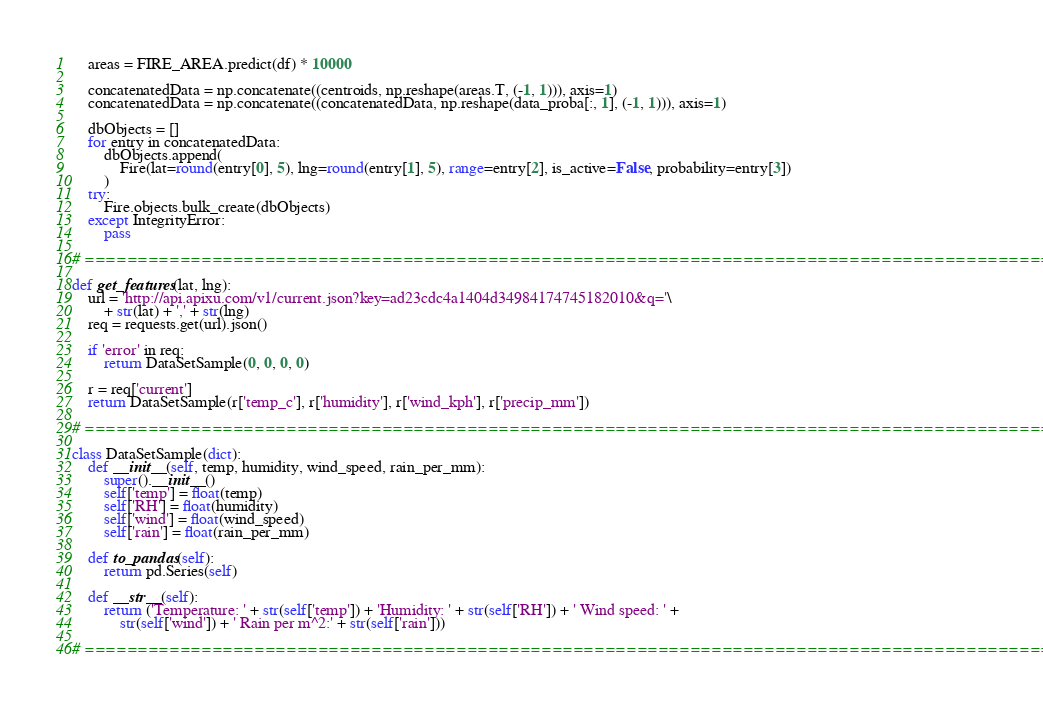<code> <loc_0><loc_0><loc_500><loc_500><_Python_>    areas = FIRE_AREA.predict(df) * 10000

    concatenatedData = np.concatenate((centroids, np.reshape(areas.T, (-1, 1))), axis=1)
    concatenatedData = np.concatenate((concatenatedData, np.reshape(data_proba[:, 1], (-1, 1))), axis=1)

    dbObjects = []
    for entry in concatenatedData:
        dbObjects.append(
            Fire(lat=round(entry[0], 5), lng=round(entry[1], 5), range=entry[2], is_active=False, probability=entry[3])
        )
    try:
        Fire.objects.bulk_create(dbObjects)
    except IntegrityError:
        pass

# ====================================================================================================

def get_features(lat, lng):
    url = 'http://api.apixu.com/v1/current.json?key=ad23cdc4a1404d34984174745182010&q='\
        + str(lat) + ',' + str(lng)
    req = requests.get(url).json()

    if 'error' in req:
        return DataSetSample(0, 0, 0, 0)

    r = req['current']
    return DataSetSample(r['temp_c'], r['humidity'], r['wind_kph'], r['precip_mm'])

# ====================================================================================================

class DataSetSample(dict):
    def __init__(self, temp, humidity, wind_speed, rain_per_mm):
        super().__init__()
        self['temp'] = float(temp)
        self['RH'] = float(humidity)
        self['wind'] = float(wind_speed)
        self['rain'] = float(rain_per_mm)

    def to_pandas(self):
        return pd.Series(self)

    def __str__(self):
        return ('Temperature: ' + str(self['temp']) + 'Humidity: ' + str(self['RH']) + ' Wind speed: ' +
            str(self['wind']) + ' Rain per m^2:' + str(self['rain']))

# ====================================================================================================
</code> 